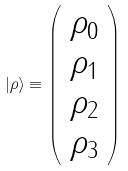Convert formula to latex. <formula><loc_0><loc_0><loc_500><loc_500>| \rho \rangle \equiv \left ( \begin{array} { l } \rho _ { 0 } \\ \rho _ { 1 } \\ \rho _ { 2 } \\ \rho _ { 3 } \end{array} \right )</formula> 